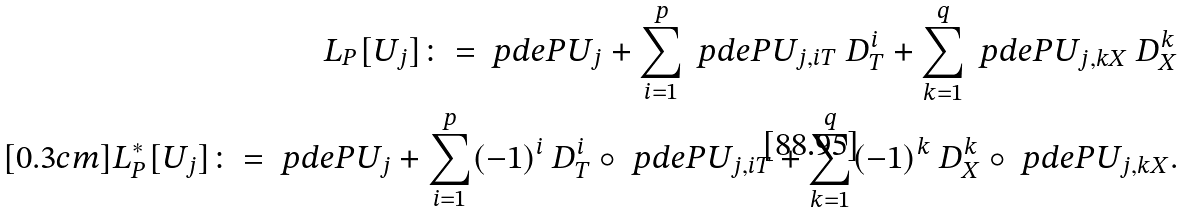<formula> <loc_0><loc_0><loc_500><loc_500>L _ { P } [ U _ { j } ] \colon = \ p d e { P } { U _ { j } } + \sum _ { i = 1 } ^ { p } \ p d e { P } { U _ { j , i T } } \ D _ { T } ^ { i } + \sum _ { k = 1 } ^ { q } \ p d e { P } { U _ { j , k X } } \ D _ { X } ^ { k } \\ [ 0 . 3 c m ] L _ { P } ^ { * } [ U _ { j } ] \colon = \ p d e { P } { U _ { j } } + \sum _ { i = 1 } ^ { p } ( - 1 ) ^ { i } \ D _ { T } ^ { i } \circ \ p d e { P } { U _ { j , i T } } + \sum _ { k = 1 } ^ { q } ( - 1 ) ^ { k } \ D _ { X } ^ { k } \circ \ p d e { P } { U _ { j , k X } } .</formula> 